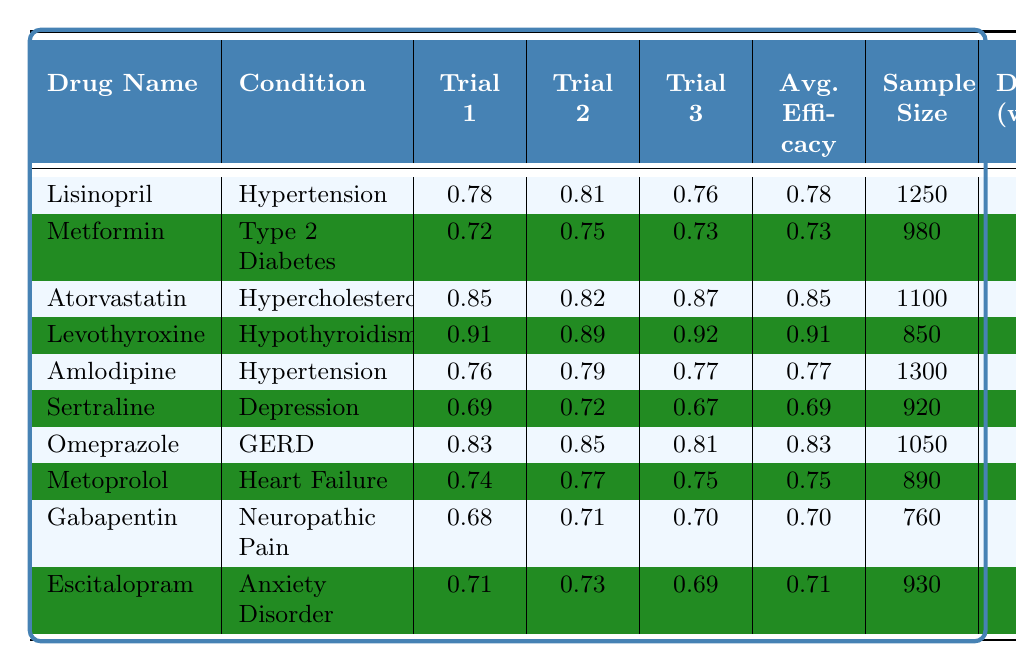What is the average efficacy rate for Atorvastatin? To find the average efficacy rate for Atorvastatin, we look at the "Avg. Efficacy" column for Atorvastatin, which is 0.85.
Answer: 0.85 Which drug has the highest side effect rate? By inspecting the "Side Effect Rate" column, Gabapentin has the highest value at 0.21.
Answer: Gabapentin What is the sample size for Levothyroxine? The "Sample Size" column lists 850 participants for Levothyroxine.
Answer: 850 Calculate the difference in average efficacy rates between Lisinopril and Sertraline. Lisinopril's average efficacy is 0.78 and Sertraline's is 0.69. The difference is 0.78 - 0.69 = 0.09.
Answer: 0.09 Is the average efficacy for Metformin greater than 0.70? The average efficacy for Metformin is 0.73, which is greater than 0.70.
Answer: Yes What is the average side effect rate for drugs treating Hypertension? The side effect rates for Lisinopril (0.12) and Amlodipine (0.11) are added: 0.12 + 0.11 = 0.23. Dividing by 2 (the number of drugs) gives an average side effect rate of 0.23 / 2 = 0.115.
Answer: 0.115 Which drug has the longest treatment duration? Looking at the "Duration (weeks)" column, Atorvastatin has the longest duration at 52 weeks.
Answer: Atorvastatin Is the recommended dosage for Omeprazole lower than that of Gabapentin? Omeprazole is recommended at 20-40 mg daily, while Gabapentin is 300-3600 mg daily, making Omeprazole's dosage lower.
Answer: Yes What is the total sample size for all drugs treating Depression and Anxiety Disorder? The sample sizes for Sertraline (920) and Escitalopram (930) are added: 920 + 930 = 1850.
Answer: 1850 Calculate the average efficacy rate for drugs with a side effect rate below 0.10. The drugs with side effect rates below 0.10 are Metformin (0.09) and Levothyroxine (0.05). Their average efficacy is (0.73 + 0.91) / 2 = 0.82.
Answer: 0.82 